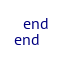<code> <loc_0><loc_0><loc_500><loc_500><_Ruby_>  end
end
</code> 